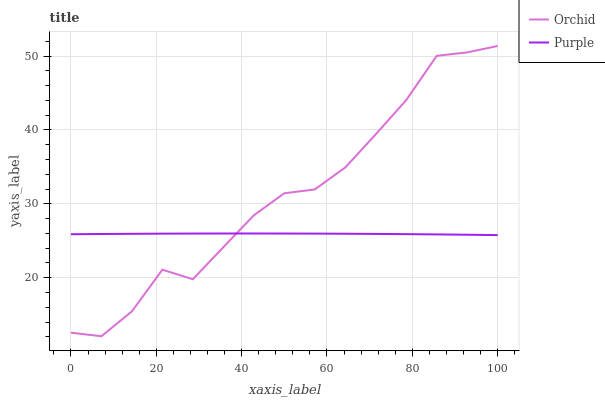Does Purple have the minimum area under the curve?
Answer yes or no. Yes. Does Orchid have the maximum area under the curve?
Answer yes or no. Yes. Does Orchid have the minimum area under the curve?
Answer yes or no. No. Is Purple the smoothest?
Answer yes or no. Yes. Is Orchid the roughest?
Answer yes or no. Yes. Is Orchid the smoothest?
Answer yes or no. No. Does Orchid have the lowest value?
Answer yes or no. Yes. Does Orchid have the highest value?
Answer yes or no. Yes. Does Purple intersect Orchid?
Answer yes or no. Yes. Is Purple less than Orchid?
Answer yes or no. No. Is Purple greater than Orchid?
Answer yes or no. No. 